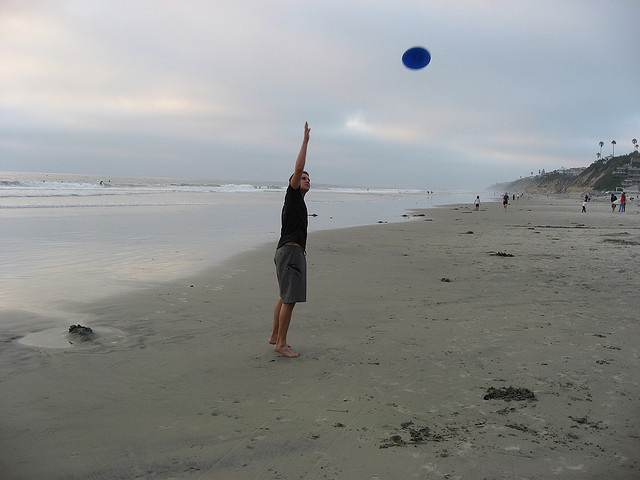Describe the objects in this image and their specific colors. I can see people in lightgray, black, gray, maroon, and darkgray tones, frisbee in lightgray, navy, gray, and darkblue tones, people in lightgray, gray, maroon, navy, and black tones, people in lightgray, black, darkgray, and gray tones, and people in lightgray, black, gray, and darkgray tones in this image. 